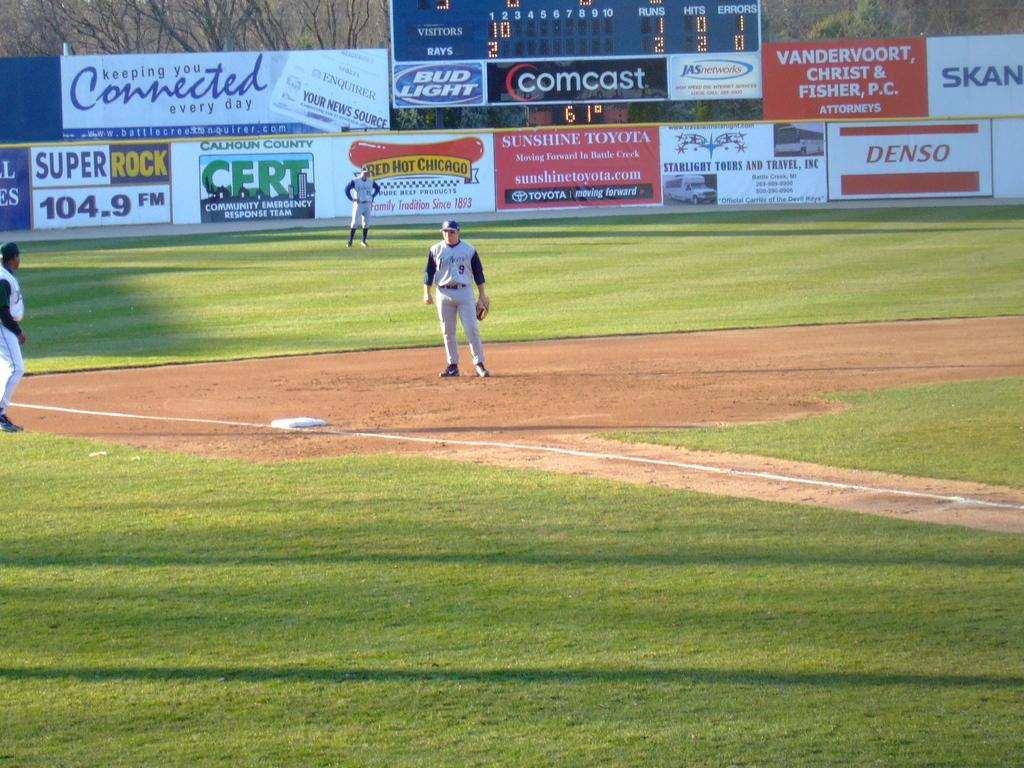<image>
Provide a brief description of the given image. A minor league baseball field is filled with ads on the walls for things like CERT. 